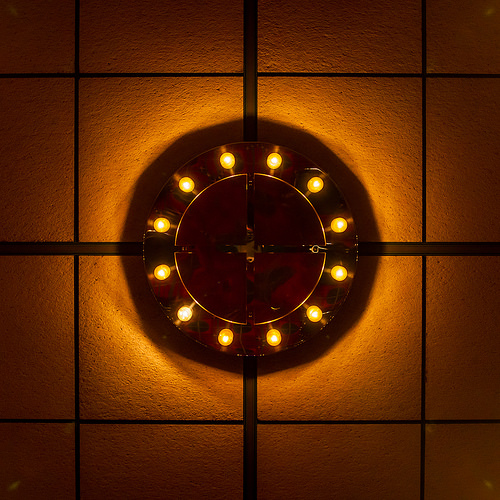<image>
Is there a shadow behind the light? Yes. From this viewpoint, the shadow is positioned behind the light, with the light partially or fully occluding the shadow. 